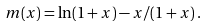<formula> <loc_0><loc_0><loc_500><loc_500>m ( x ) = \ln ( 1 + x ) - x / ( 1 + x ) \, .</formula> 